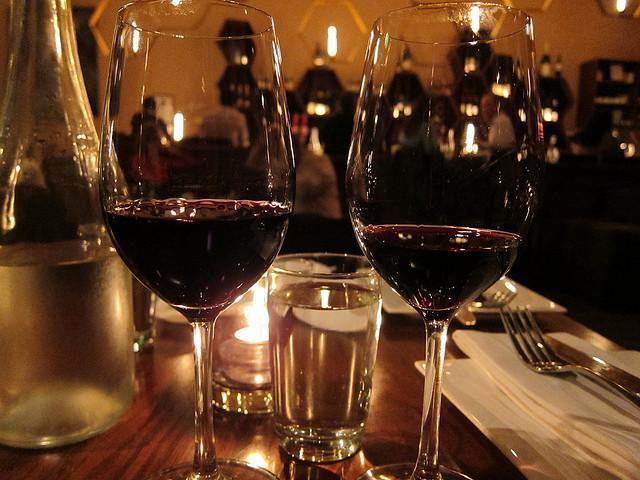How many wine glasses are there?
Give a very brief answer. 2. How many cups are in the picture?
Give a very brief answer. 2. How many bottles are in the photo?
Give a very brief answer. 1. How many men are playing?
Give a very brief answer. 0. 